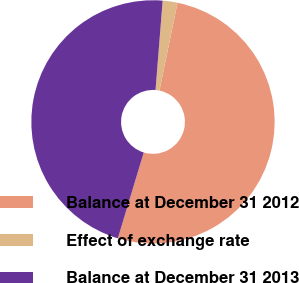Convert chart. <chart><loc_0><loc_0><loc_500><loc_500><pie_chart><fcel>Balance at December 31 2012<fcel>Effect of exchange rate<fcel>Balance at December 31 2013<nl><fcel>51.43%<fcel>1.97%<fcel>46.6%<nl></chart> 